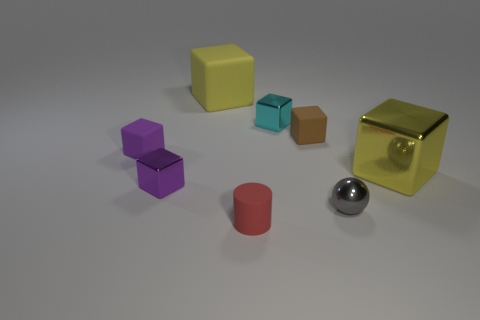Is the large rubber cube the same color as the large metal block?
Offer a terse response. Yes. What number of objects are either large yellow blocks that are to the right of the yellow rubber cube or big yellow objects that are on the left side of the large yellow metal block?
Provide a short and direct response. 2. Are there any other metallic things of the same shape as the purple shiny thing?
Ensure brevity in your answer.  Yes. What is the material of the big cube that is the same color as the big metallic object?
Offer a very short reply. Rubber. How many rubber things are small yellow cubes or small balls?
Provide a short and direct response. 0. What is the shape of the large matte thing?
Ensure brevity in your answer.  Cube. How many other small gray spheres have the same material as the tiny gray ball?
Make the answer very short. 0. There is a large block that is made of the same material as the small red cylinder; what color is it?
Keep it short and to the point. Yellow. Is the size of the shiny thing behind the yellow metallic block the same as the brown matte cube?
Your response must be concise. Yes. What is the color of the other small metallic thing that is the same shape as the purple metal object?
Give a very brief answer. Cyan. 